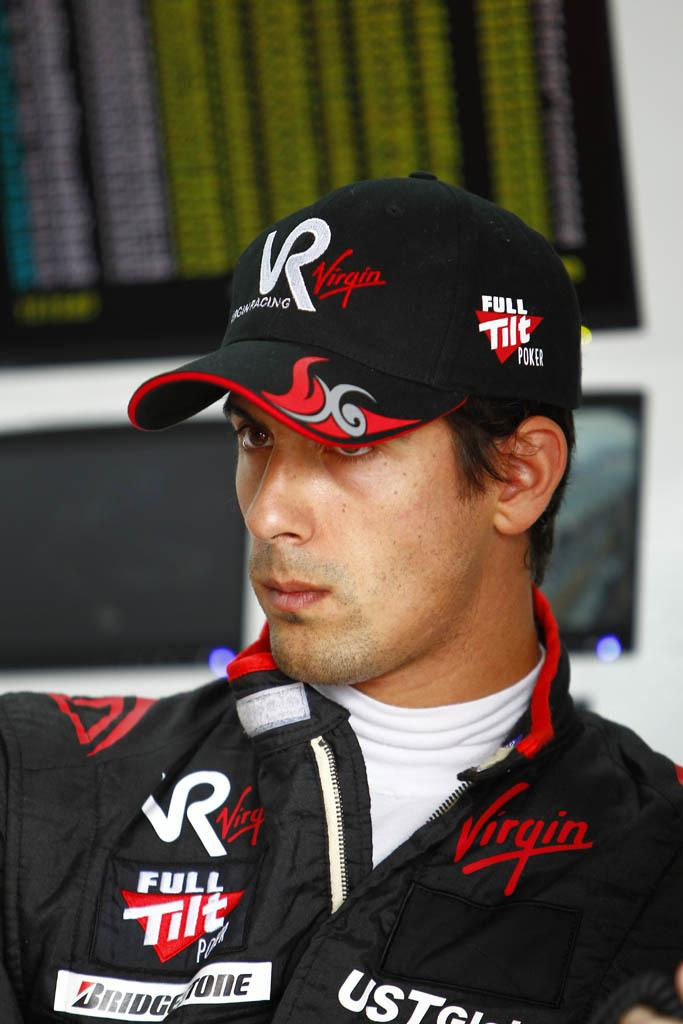Who is the main subject in the image? There is a man in the image. What is the man wearing on his upper body? The man is wearing a black jersey and a white t-shirt underneath. What type of headwear is the man wearing? The man is wearing a cap. In which direction is the man looking? The man is staring in the front. What type of butter is being used in the image? There is no butter present in the image. How does the man's temper affect the playground in the image? There is no playground or mention of the man's temper in the image. 